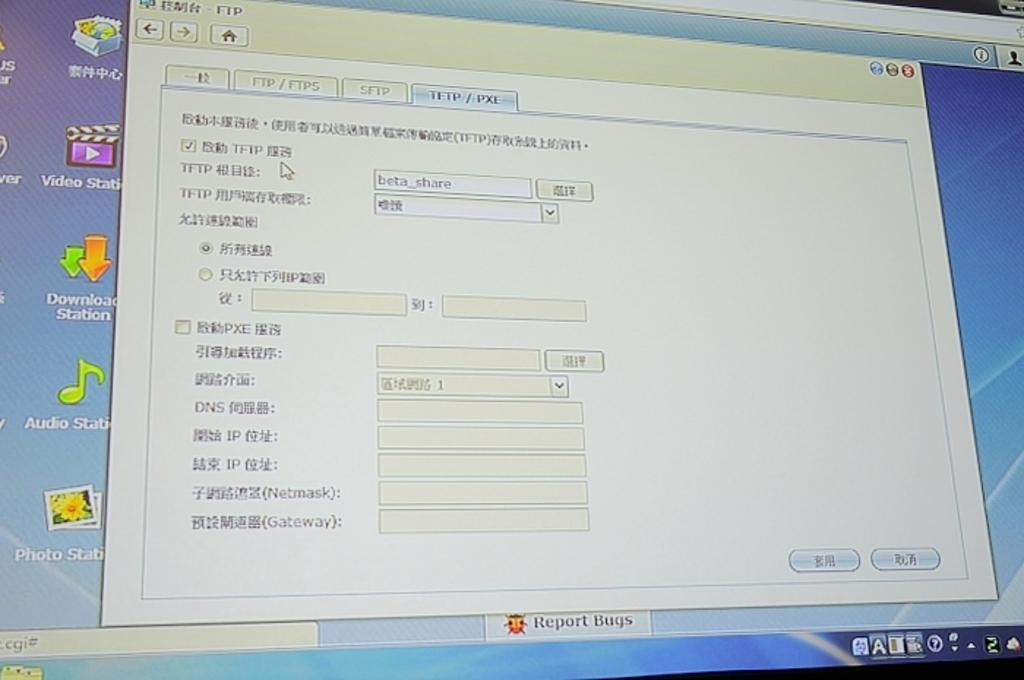<image>
Give a short and clear explanation of the subsequent image. A computer screen shows several shortcut icons to programs such as photo, video, and download stations. 